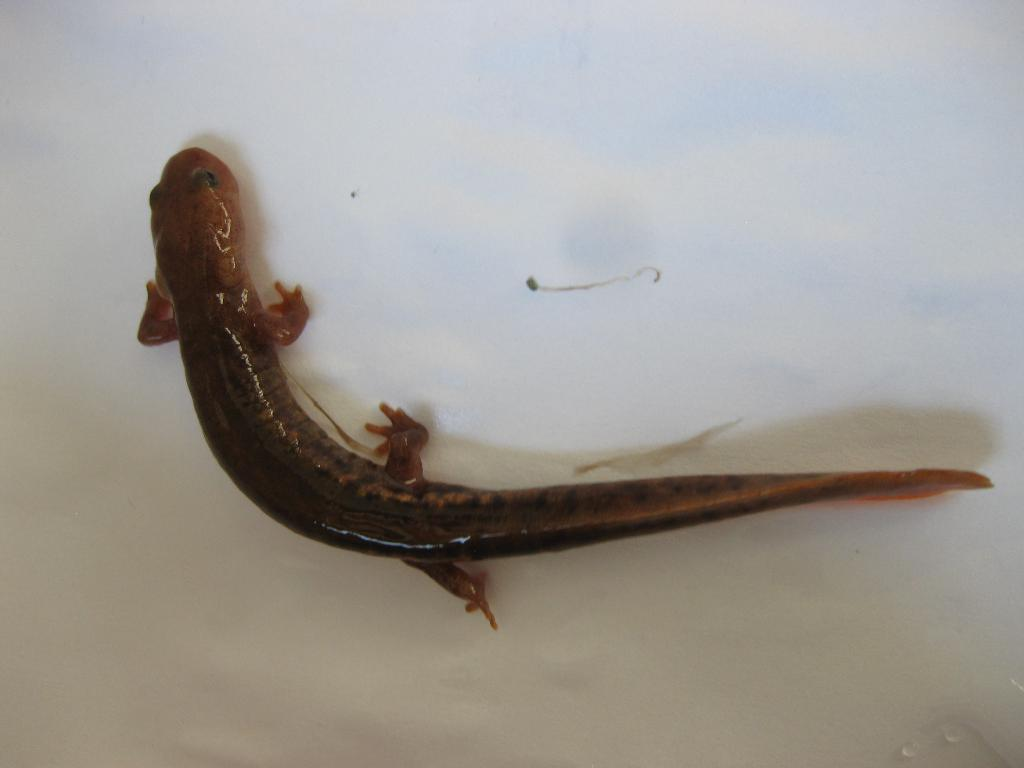What type of animal is in the image? There is a lizard in the image. Where is the lizard located? The lizard is on the wall. What type of vessel is being used by the lizard in the image? There is no vessel present in the image, as it features a lizard on the wall. What school is the lizard attending in the image? There is no indication of a school or education in the image; it simply shows a lizard on the wall. 